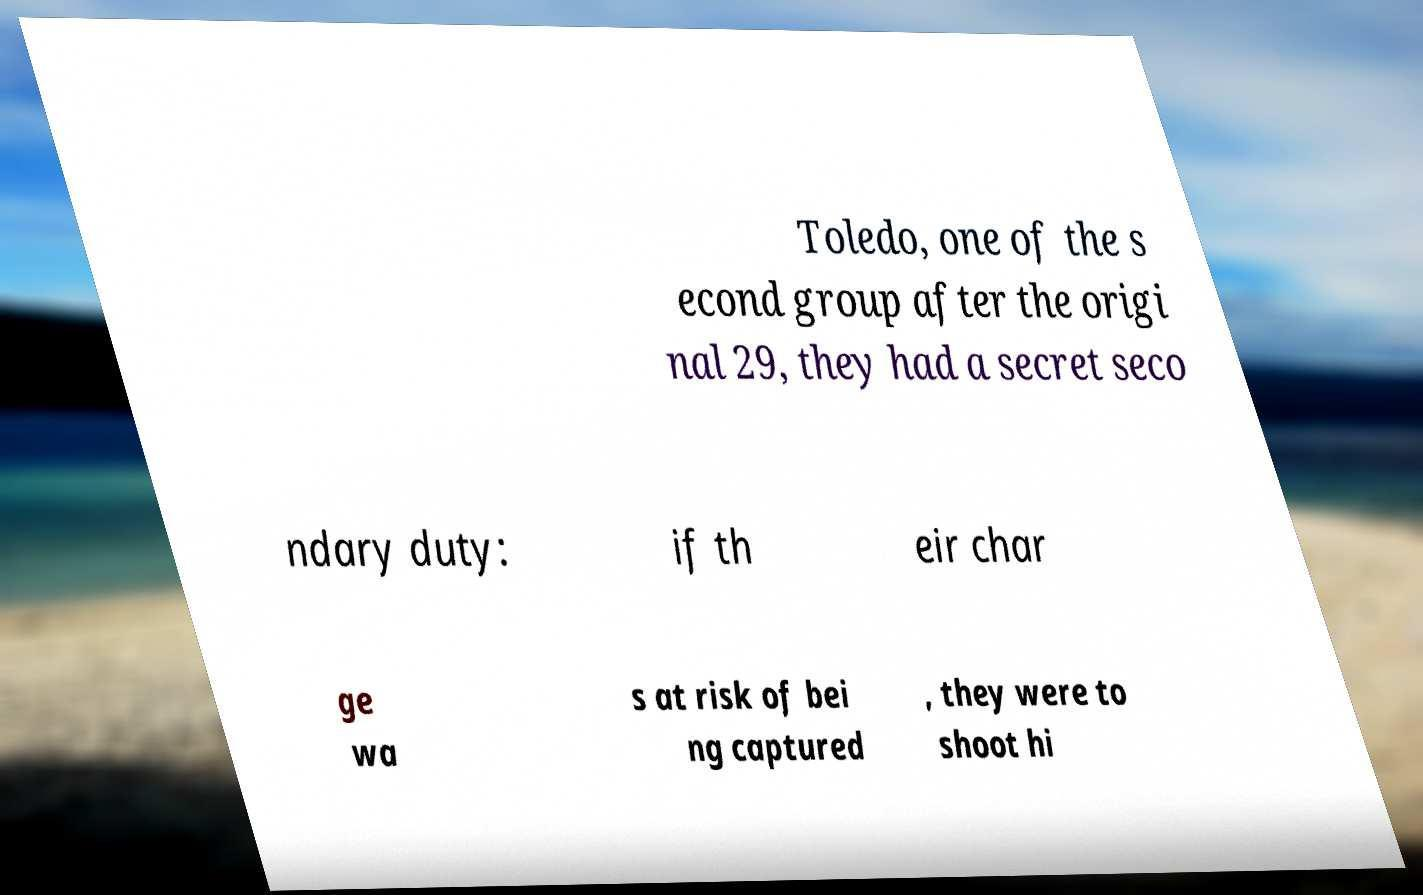Can you accurately transcribe the text from the provided image for me? Toledo, one of the s econd group after the origi nal 29, they had a secret seco ndary duty: if th eir char ge wa s at risk of bei ng captured , they were to shoot hi 